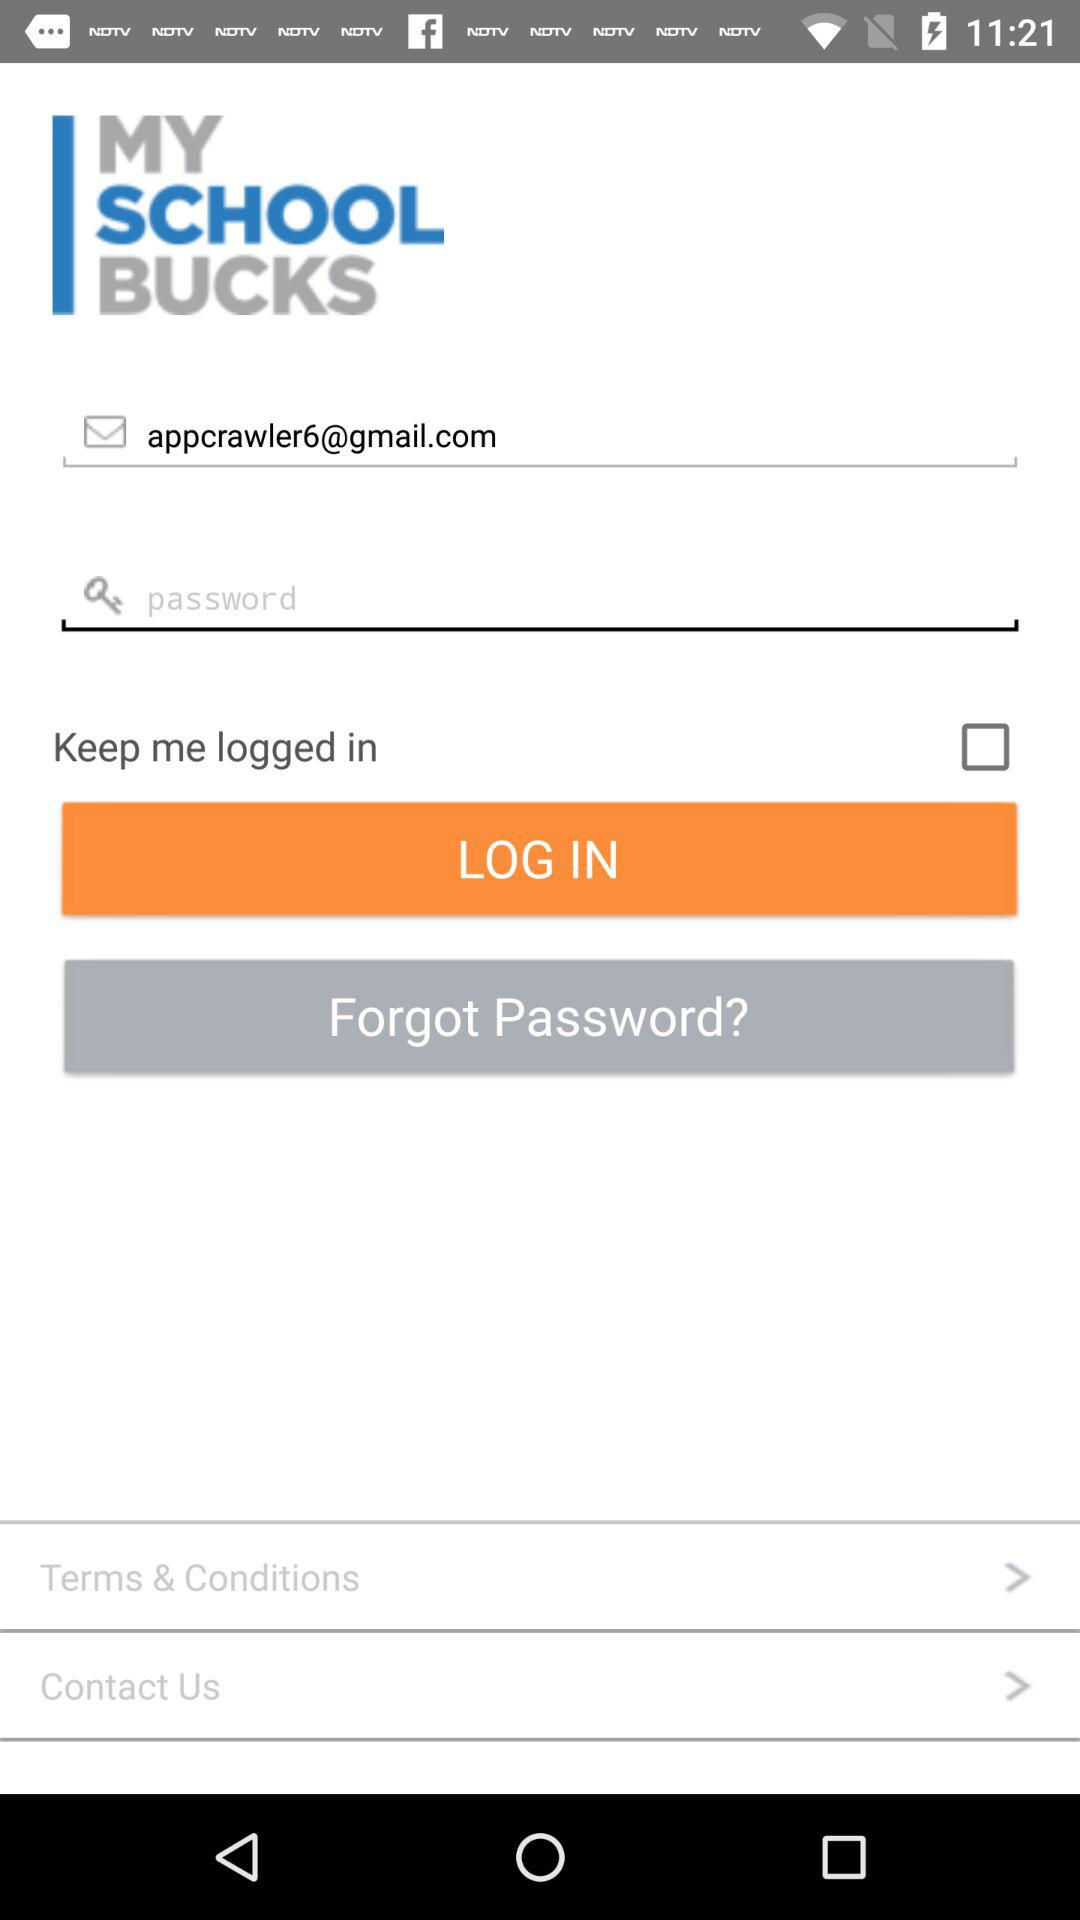What is the status of keep me logged in? The status is off. 